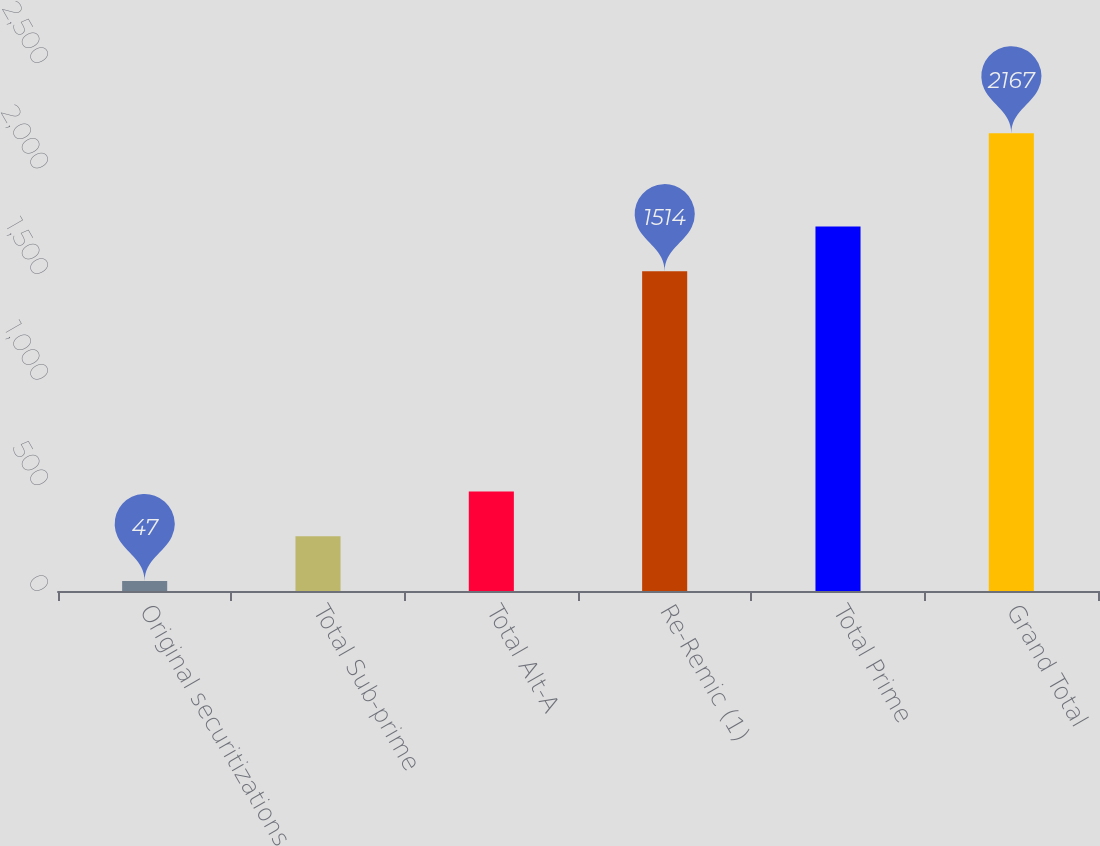Convert chart. <chart><loc_0><loc_0><loc_500><loc_500><bar_chart><fcel>Original securitizations<fcel>Total Sub-prime<fcel>Total Alt-A<fcel>Re-Remic (1)<fcel>Total Prime<fcel>Grand Total<nl><fcel>47<fcel>259<fcel>471<fcel>1514<fcel>1726<fcel>2167<nl></chart> 